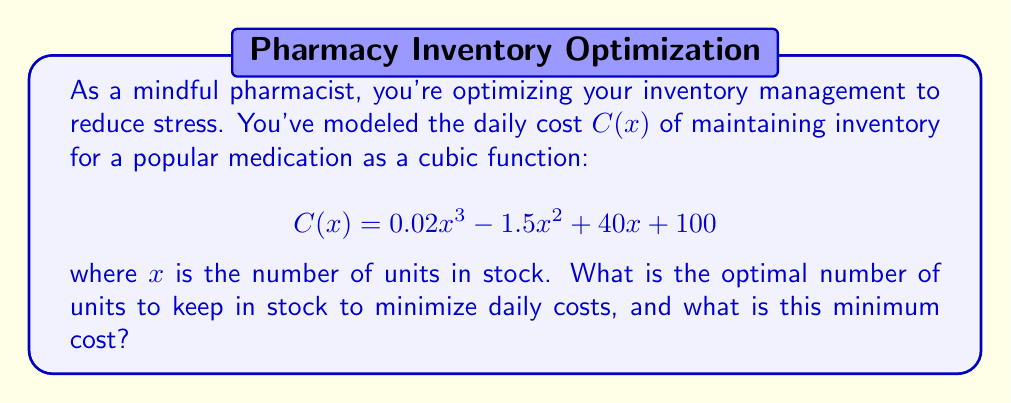Can you answer this question? To find the optimal number of units and the minimum cost, we need to follow these steps:

1) The minimum point of the cubic function occurs where its derivative equals zero. Let's find the derivative of $C(x)$:

   $$C'(x) = 0.06x^2 - 3x + 40$$

2) Set $C'(x) = 0$ and solve for $x$:

   $$0.06x^2 - 3x + 40 = 0$$

3) This is a quadratic equation. We can solve it using the quadratic formula:
   
   $$x = \frac{-b \pm \sqrt{b^2 - 4ac}}{2a}$$

   where $a = 0.06$, $b = -3$, and $c = 40$

4) Substituting these values:

   $$x = \frac{3 \pm \sqrt{9 - 9.6}}{0.12} = \frac{3 \pm \sqrt{-0.6}}{0.12}$$

5) Since we can't have a negative value under the square root, we know there's only one real solution:

   $$x = \frac{3}{0.12} = 25$$

6) To confirm this is a minimum (not a maximum), we can check that $C''(x) > 0$ at $x = 25$:

   $$C''(x) = 0.12x - 3$$
   $$C''(25) = 0.12(25) - 3 = 3 - 3 = 0$$

   Since $C''(25) = 0$, we need to check points on either side to confirm it's a local minimum.

7) Now that we know the optimal number of units is 25, we can calculate the minimum cost by plugging this back into our original function:

   $$C(25) = 0.02(25)^3 - 1.5(25)^2 + 40(25) + 100$$
   $$= 312.5 - 937.5 + 1000 + 100 = 475$$

Therefore, the optimal number of units to keep in stock is 25, and the minimum daily cost is $475.
Answer: The optimal number of units to keep in stock is 25, and the minimum daily cost is $475. 